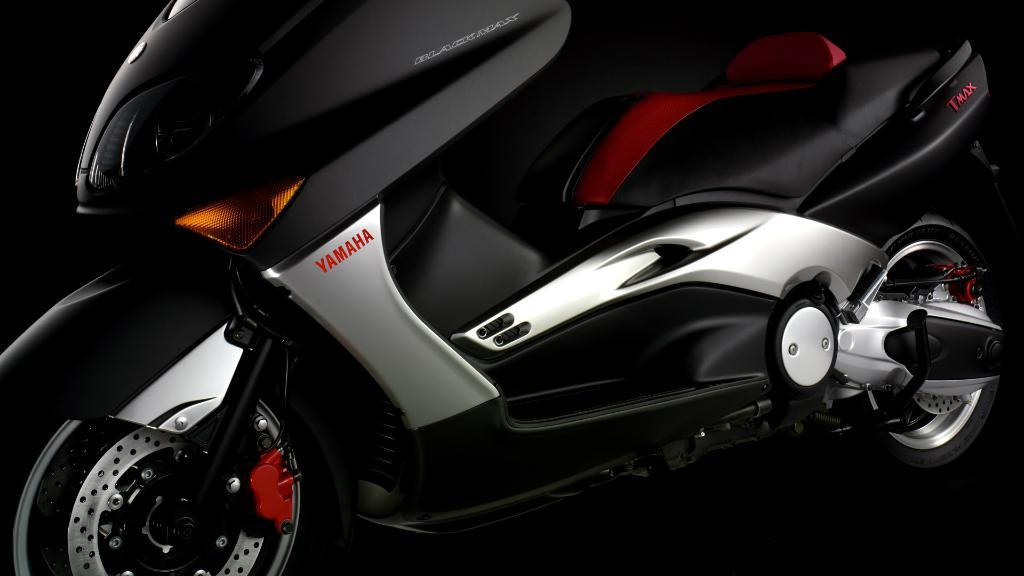What type of motor vehicle is in the image? The specific type of motor vehicle is not mentioned, but there is a motor vehicle present in the image. On what surface is the motor vehicle placed? The motor vehicle is placed on a surface, but the type of surface is not specified. How many goldfish are swimming in the motor vehicle in the image? There are no goldfish present in the image, as it features a motor vehicle placed on a surface. 